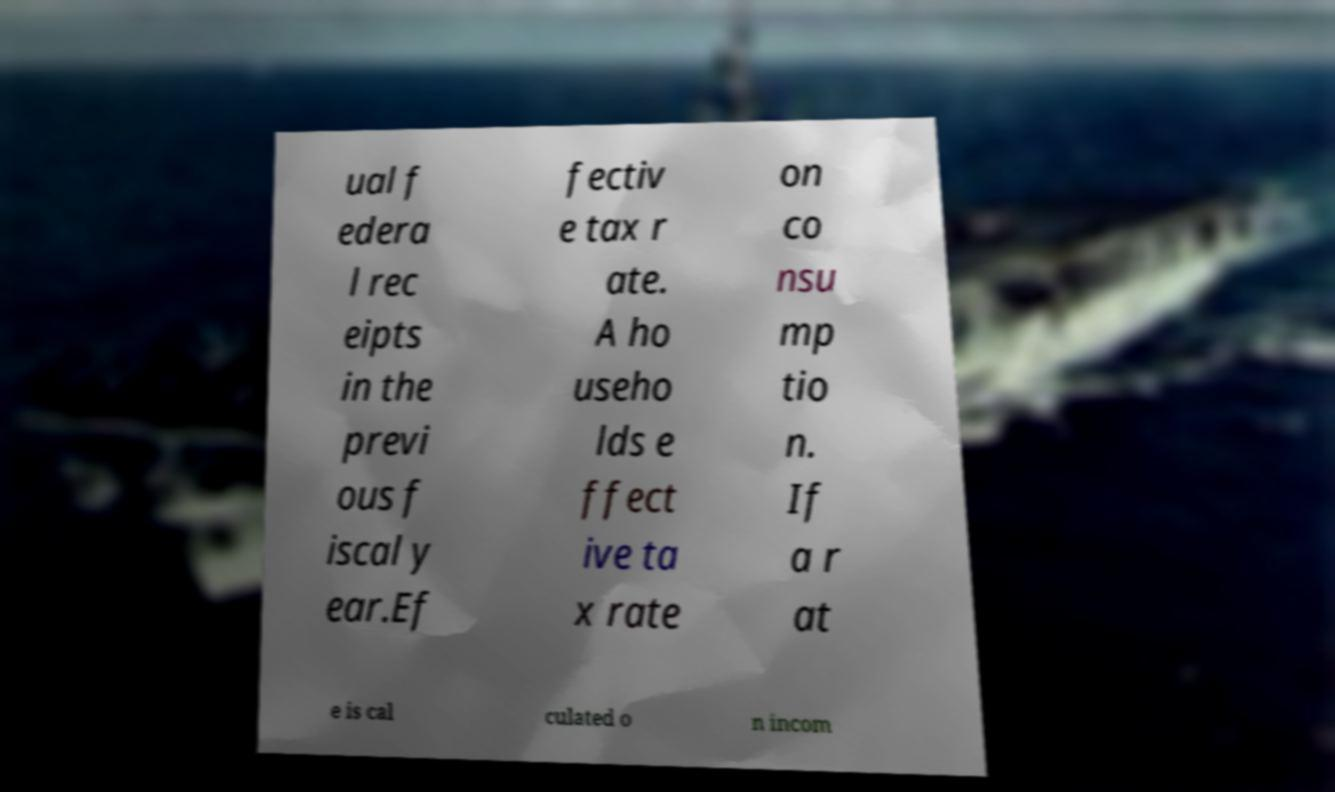What messages or text are displayed in this image? I need them in a readable, typed format. ual f edera l rec eipts in the previ ous f iscal y ear.Ef fectiv e tax r ate. A ho useho lds e ffect ive ta x rate on co nsu mp tio n. If a r at e is cal culated o n incom 